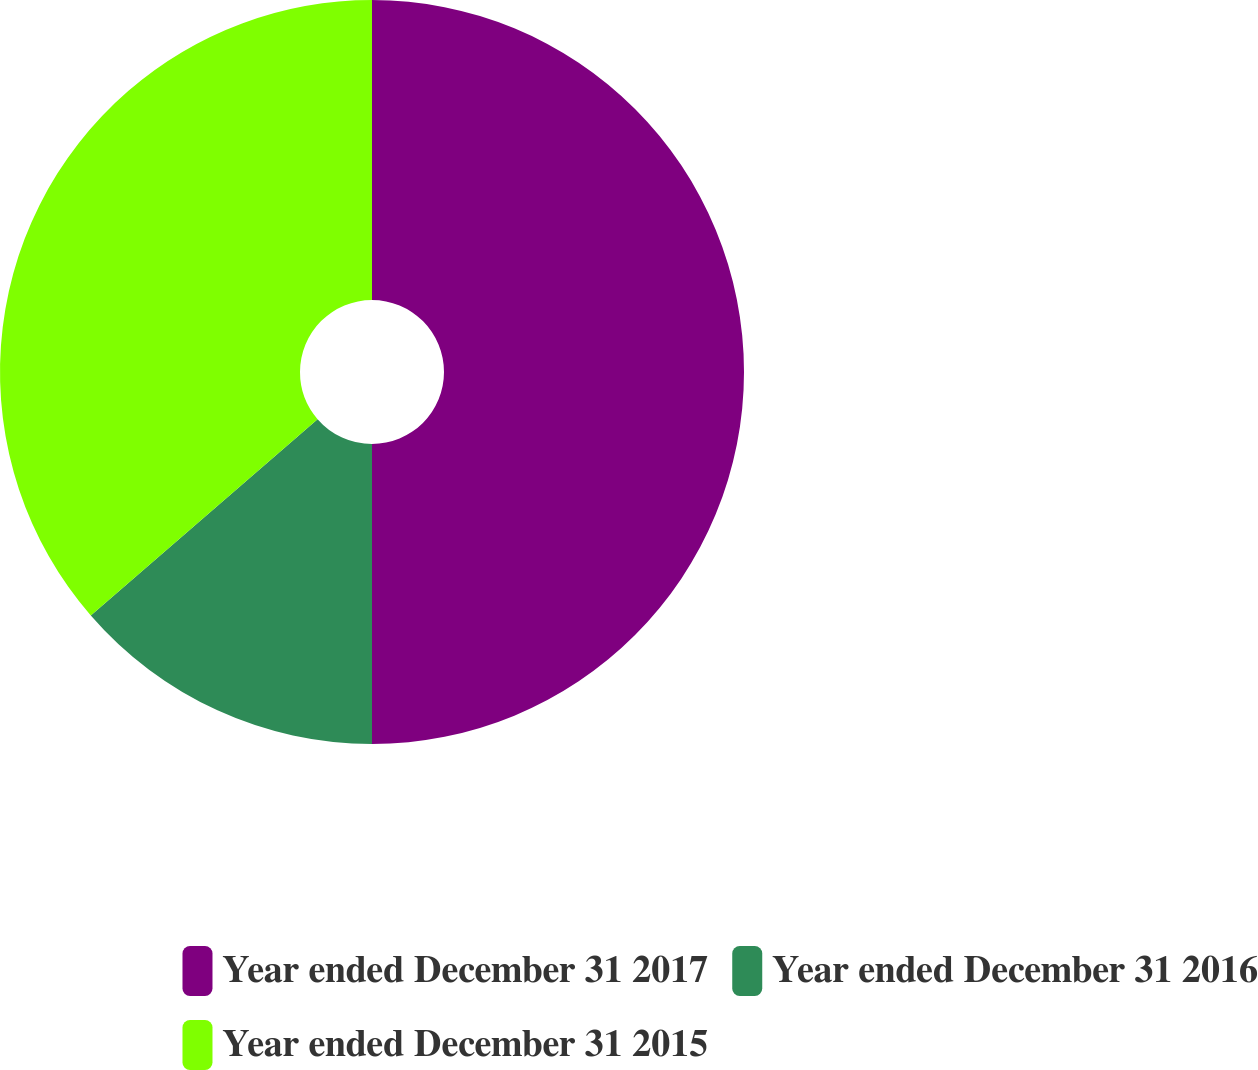Convert chart. <chart><loc_0><loc_0><loc_500><loc_500><pie_chart><fcel>Year ended December 31 2017<fcel>Year ended December 31 2016<fcel>Year ended December 31 2015<nl><fcel>50.0%<fcel>13.64%<fcel>36.36%<nl></chart> 